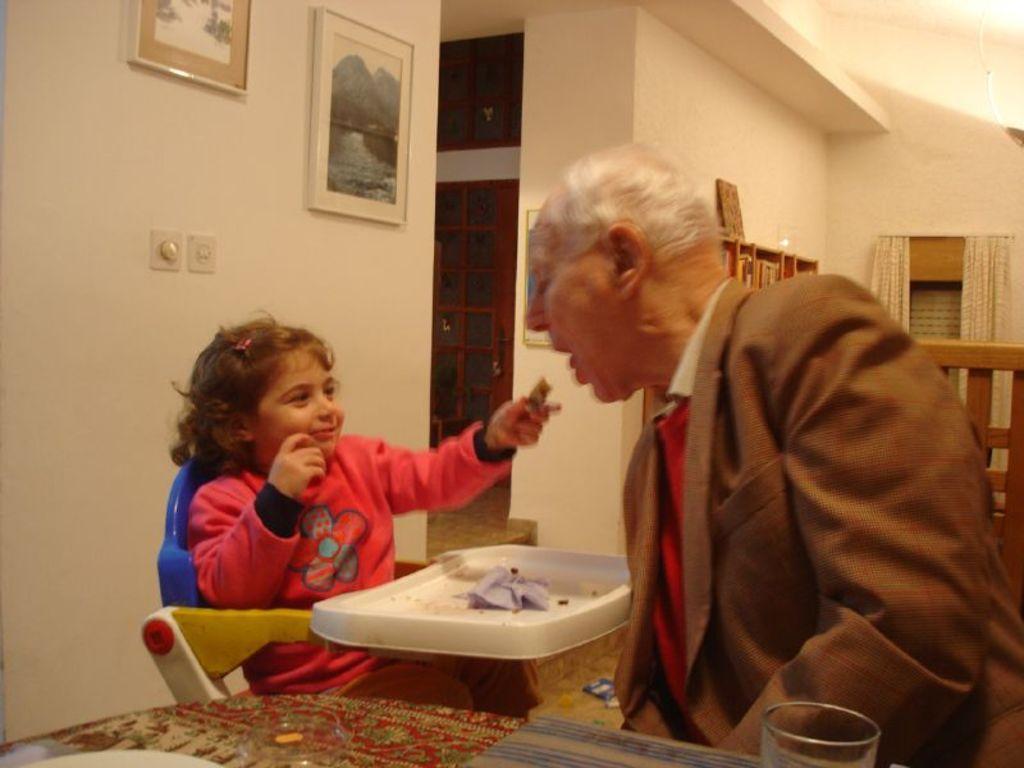Please provide a concise description of this image. There is a man sitting on chair,in front of him we can see glasses,plate and mat on the table. There is a girl sitting on chair and holding a food,behind her we can see frames on a wall. In the background we can see all,objects on wooden object,curtains,door and window. 